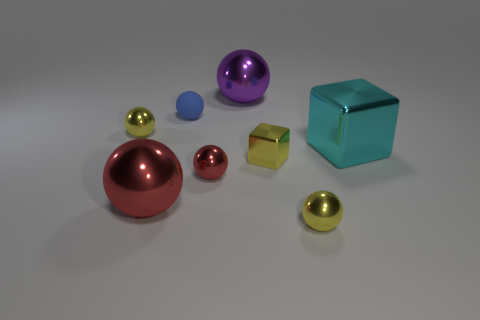What number of large red things have the same shape as the tiny blue rubber object?
Ensure brevity in your answer.  1. What is the color of the block that is the same size as the rubber thing?
Provide a short and direct response. Yellow. What is the color of the large metal ball right of the red thing in front of the red metallic ball that is right of the blue thing?
Provide a short and direct response. Purple. Does the blue thing have the same size as the purple object that is left of the cyan shiny thing?
Give a very brief answer. No. How many things are tiny objects or small green matte cylinders?
Provide a short and direct response. 5. Are there any blue objects that have the same material as the small red sphere?
Provide a succinct answer. No. There is a object that is on the left side of the big metallic ball left of the small red sphere; what is its color?
Your answer should be very brief. Yellow. Is the size of the blue thing the same as the cyan metal object?
Offer a very short reply. No. How many cylinders are either cyan metallic things or red metallic objects?
Offer a terse response. 0. There is a yellow shiny thing that is behind the big cyan metallic object; what number of blue objects are in front of it?
Make the answer very short. 0. 